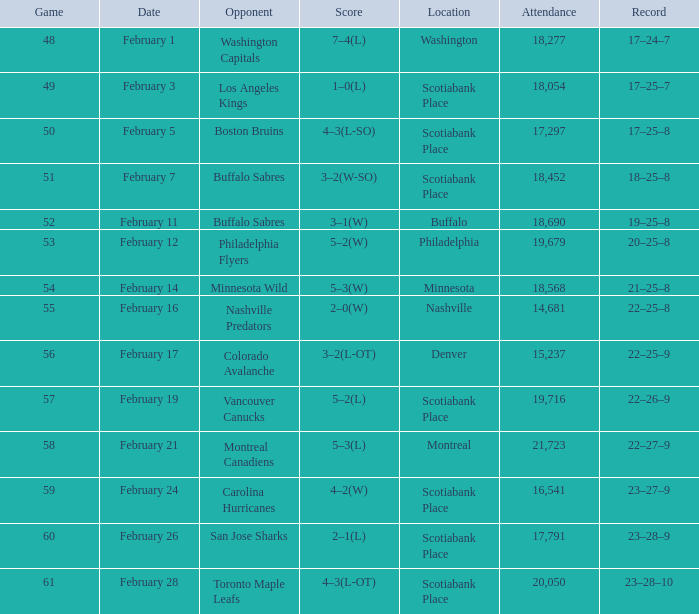On february 24th, which ordinary game had a crowd size of less than 16,541 people? None. 